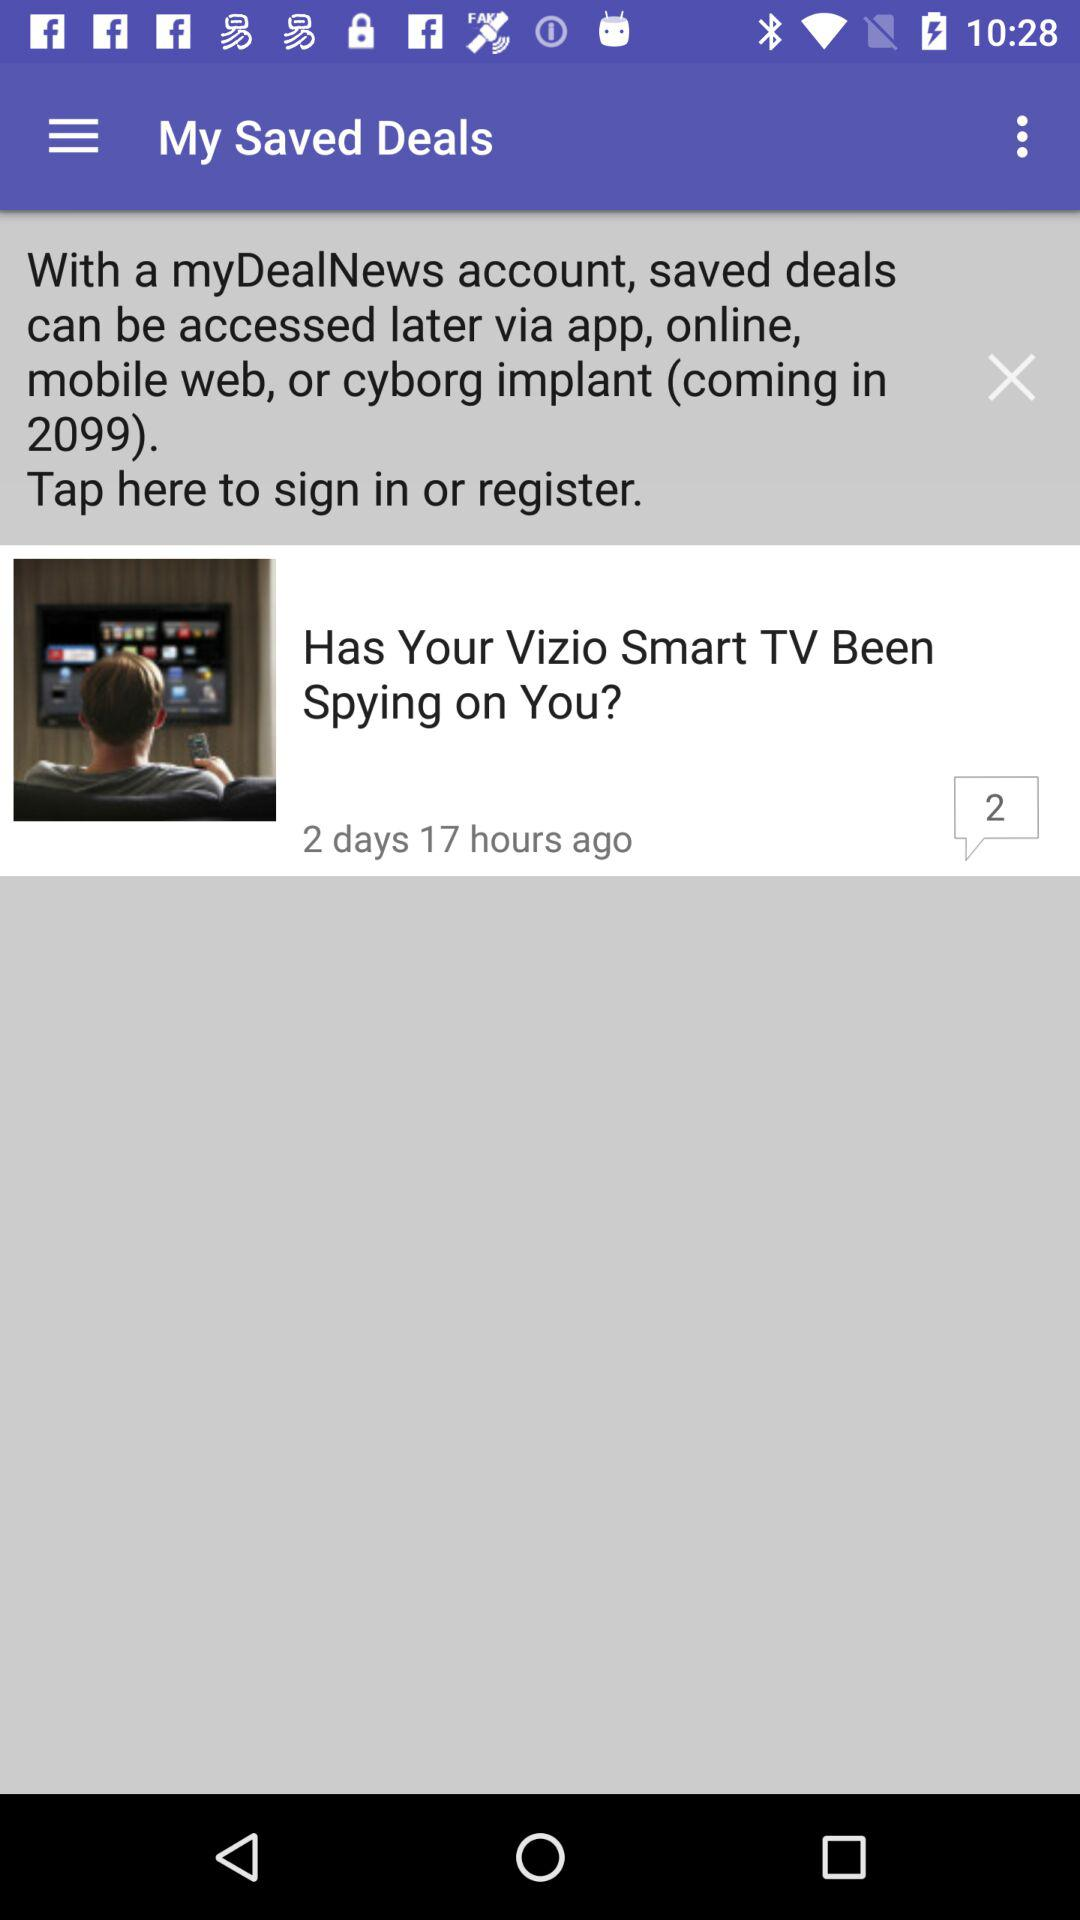When was the "Vizio Smart TV" deal added? The "Vizio Smart TV" deal was added 2 days 17 hours ago. 